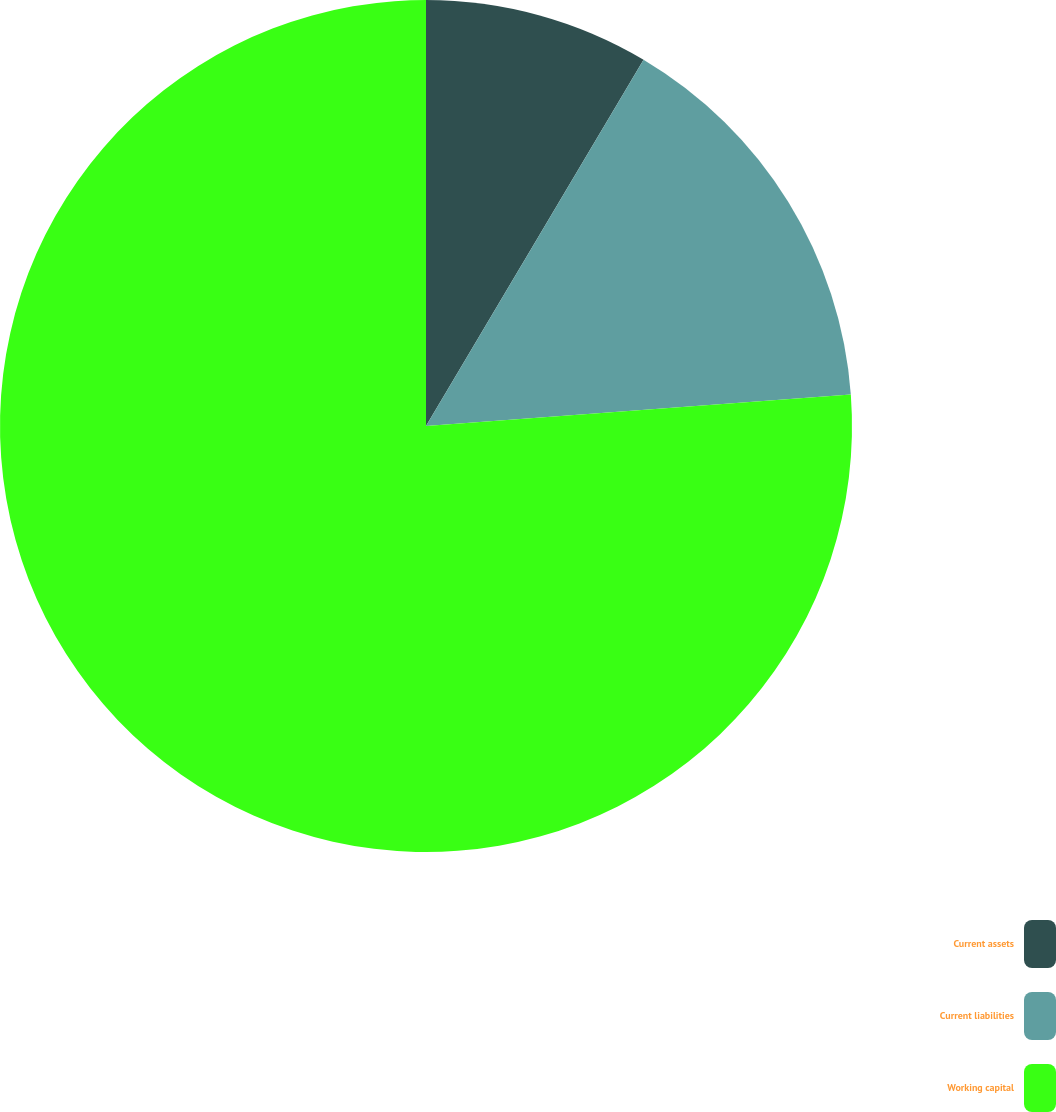Convert chart. <chart><loc_0><loc_0><loc_500><loc_500><pie_chart><fcel>Current assets<fcel>Current liabilities<fcel>Working capital<nl><fcel>8.53%<fcel>15.29%<fcel>76.18%<nl></chart> 